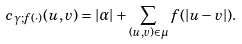Convert formula to latex. <formula><loc_0><loc_0><loc_500><loc_500>c _ { \gamma ; f ( \cdot ) } ( { u } , { v } ) = | \alpha | + \sum _ { ( u , v ) \in \mu } f ( | u - v | ) .</formula> 